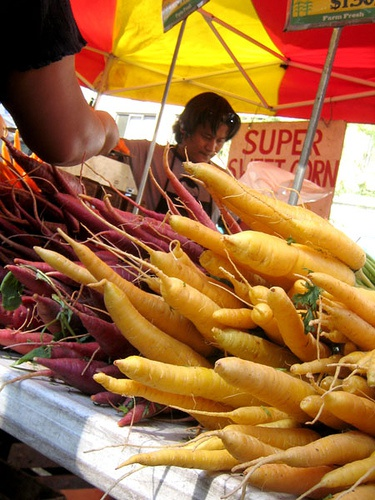Describe the objects in this image and their specific colors. I can see umbrella in black, gold, red, orange, and brown tones, people in black, maroon, and brown tones, people in black, maroon, and brown tones, carrot in black, orange, khaki, and gold tones, and carrot in black, olive, orange, and gold tones in this image. 